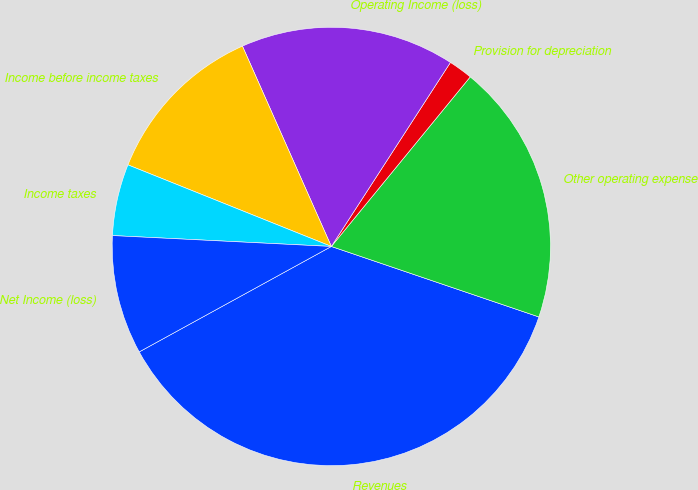Convert chart. <chart><loc_0><loc_0><loc_500><loc_500><pie_chart><fcel>Revenues<fcel>Other operating expense<fcel>Provision for depreciation<fcel>Operating Income (loss)<fcel>Income before income taxes<fcel>Income taxes<fcel>Net Income (loss)<nl><fcel>36.8%<fcel>19.29%<fcel>1.78%<fcel>15.79%<fcel>12.28%<fcel>5.28%<fcel>8.78%<nl></chart> 